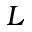Convert formula to latex. <formula><loc_0><loc_0><loc_500><loc_500>L</formula> 